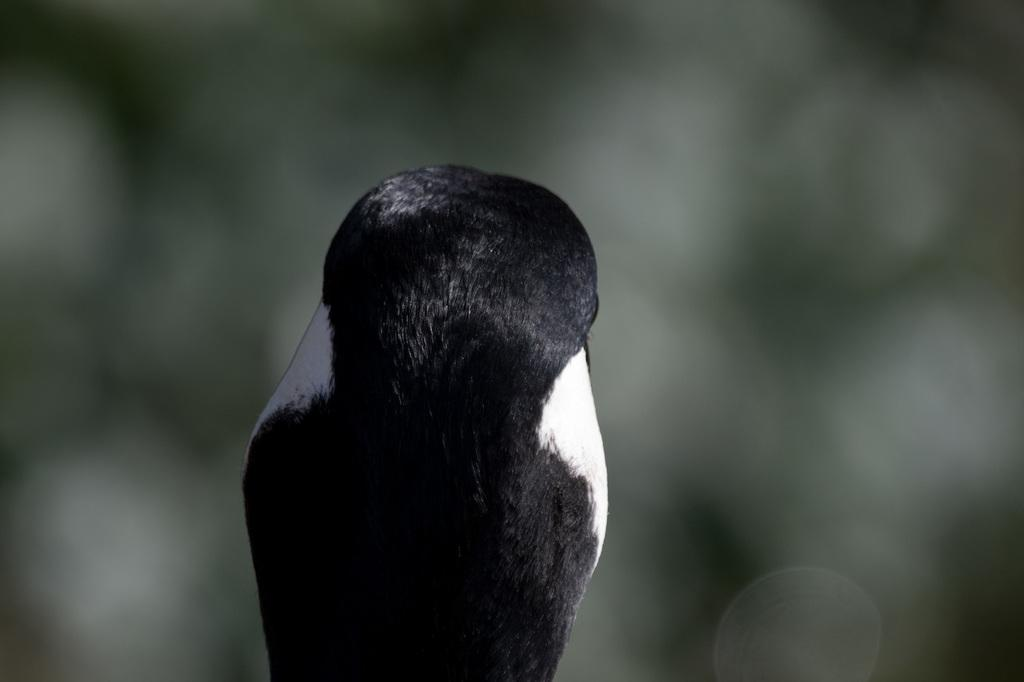What type of creature is present in the image? There is an animal in the image. How is the animal positioned in the image? The animal is in a back pose. What can be observed about the background of the image? The background of the image is blurred. What type of pen is being used by the animal in the image? There is no pen present in the image, and the animal is not using any pen. 